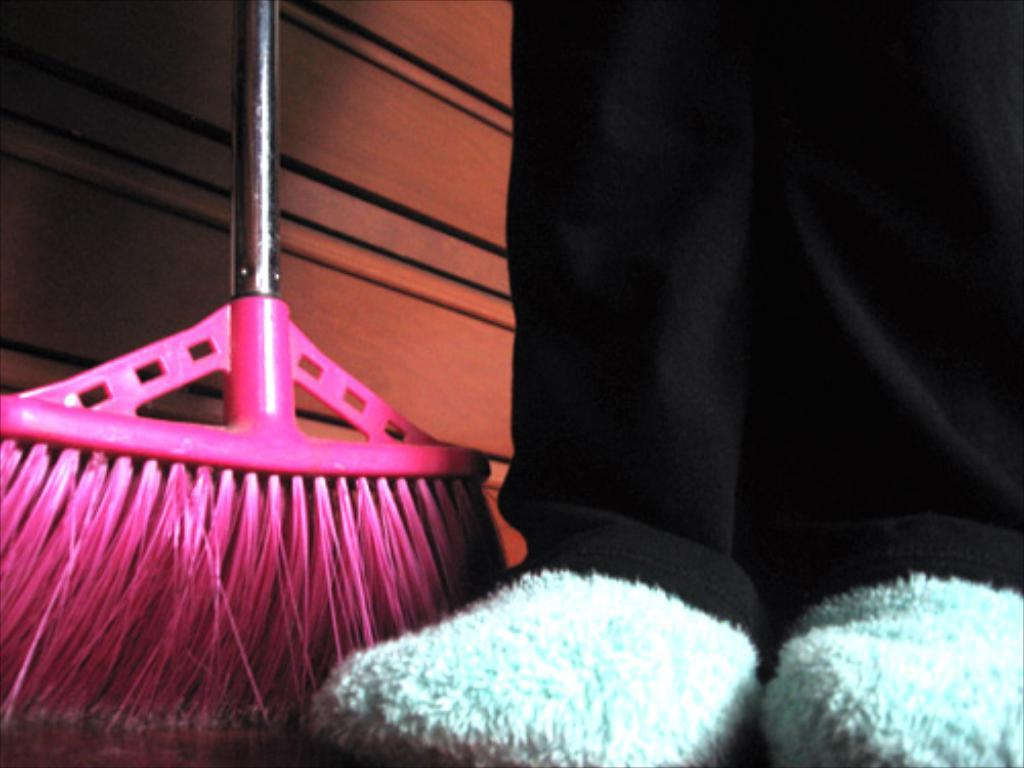What can be seen in the image related to a person? There is a person in the image. What type of clothing is the person wearing on their lower body? The person is wearing black pants. What type of footwear is the person wearing? The person is wearing footwear. What object can be seen in the image that is typically used for cleaning? There is a pink and silver color broomstick in the image. Where is the broomstick located in relation to the person? The broomstick is next to the person. What type of wall can be seen in the image? There is a brown color wooden wall in the image. What type of linen is being used by the person in the image? There is no mention of linen in the image. --- Facts: 1. There is a person in the image. 2. The person is holding a book. 3. The book is open. 4. The person is sitting on a chair. 5. The chair is made of wood. Absurd Topics: robot Conversation: What can be seen in the image related to a person? There is a person in the image. What is the person holding in the image? The person is holding a book. What is the state of the book in the image? The book is open. What is the person doing in the image? The person is sitting on a chair. What is the chair made of in the image? The chair is made of wood. Reasoning: Let's think step by step in order to produce the conversation. We start by identifying the main subject in the image, which is the person. Then, we describe what the person is holding, which is a book. Next, we mention the state of the book, which is open. After that, we describe the action of the person, which is sitting on a chair. Finally, we describe the type of material the chair is made of, which is wood. Absurd Question/Answer: What type of robot can be seen in the image? There is no mention of a robot in the image. 